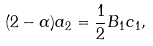<formula> <loc_0><loc_0><loc_500><loc_500>( 2 - \alpha ) a _ { 2 } = \frac { 1 } { 2 } B _ { 1 } c _ { 1 } ,</formula> 